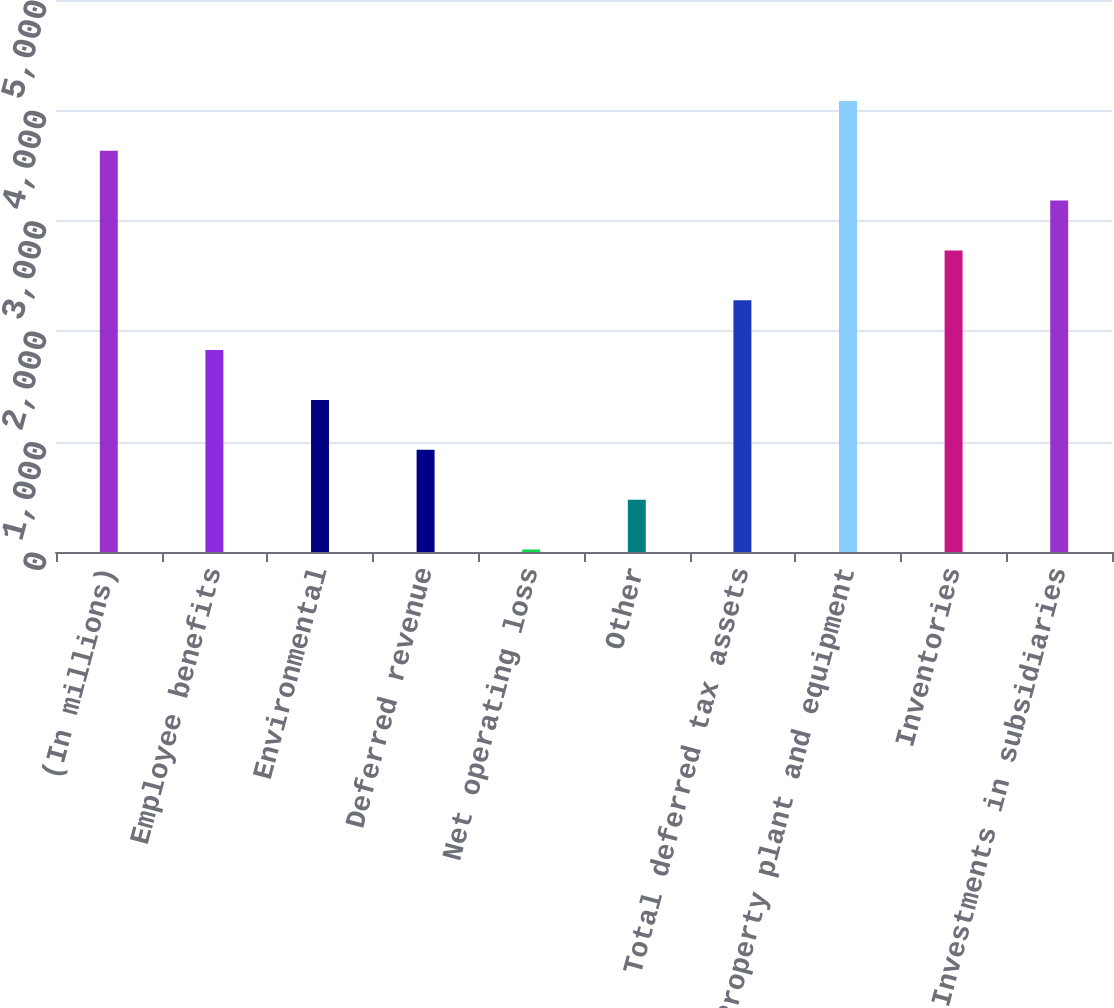Convert chart to OTSL. <chart><loc_0><loc_0><loc_500><loc_500><bar_chart><fcel>(In millions)<fcel>Employee benefits<fcel>Environmental<fcel>Deferred revenue<fcel>Net operating loss<fcel>Other<fcel>Total deferred tax assets<fcel>Property plant and equipment<fcel>Inventories<fcel>Investments in subsidiaries<nl><fcel>3634.2<fcel>1828.6<fcel>1377.2<fcel>925.8<fcel>23<fcel>474.4<fcel>2280<fcel>4085.6<fcel>2731.4<fcel>3182.8<nl></chart> 